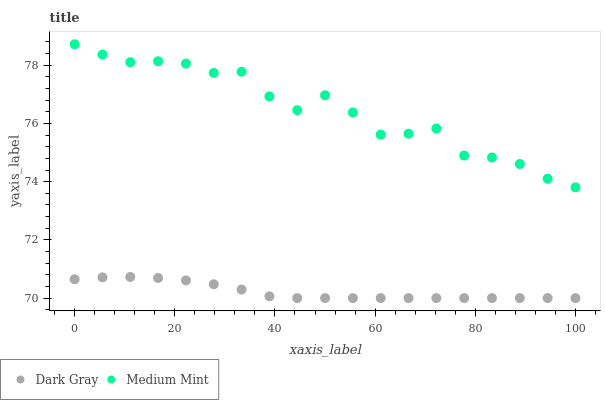Does Dark Gray have the minimum area under the curve?
Answer yes or no. Yes. Does Medium Mint have the maximum area under the curve?
Answer yes or no. Yes. Does Medium Mint have the minimum area under the curve?
Answer yes or no. No. Is Dark Gray the smoothest?
Answer yes or no. Yes. Is Medium Mint the roughest?
Answer yes or no. Yes. Is Medium Mint the smoothest?
Answer yes or no. No. Does Dark Gray have the lowest value?
Answer yes or no. Yes. Does Medium Mint have the lowest value?
Answer yes or no. No. Does Medium Mint have the highest value?
Answer yes or no. Yes. Is Dark Gray less than Medium Mint?
Answer yes or no. Yes. Is Medium Mint greater than Dark Gray?
Answer yes or no. Yes. Does Dark Gray intersect Medium Mint?
Answer yes or no. No. 